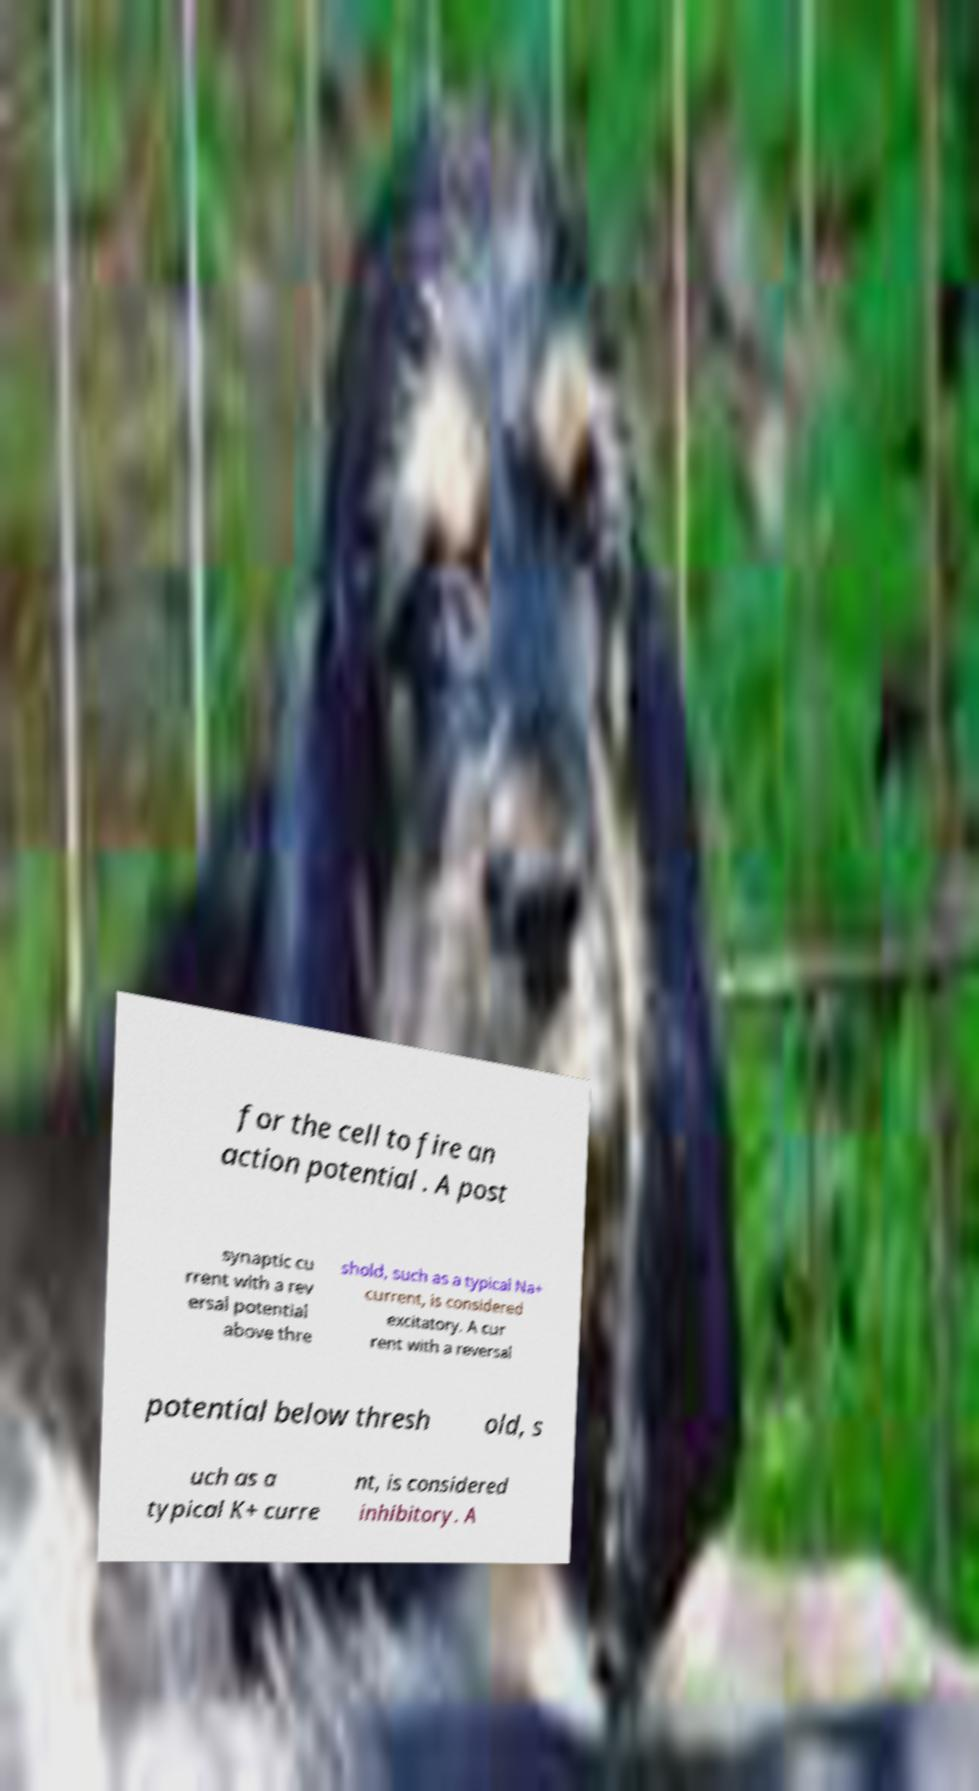Can you read and provide the text displayed in the image?This photo seems to have some interesting text. Can you extract and type it out for me? for the cell to fire an action potential . A post synaptic cu rrent with a rev ersal potential above thre shold, such as a typical Na+ current, is considered excitatory. A cur rent with a reversal potential below thresh old, s uch as a typical K+ curre nt, is considered inhibitory. A 